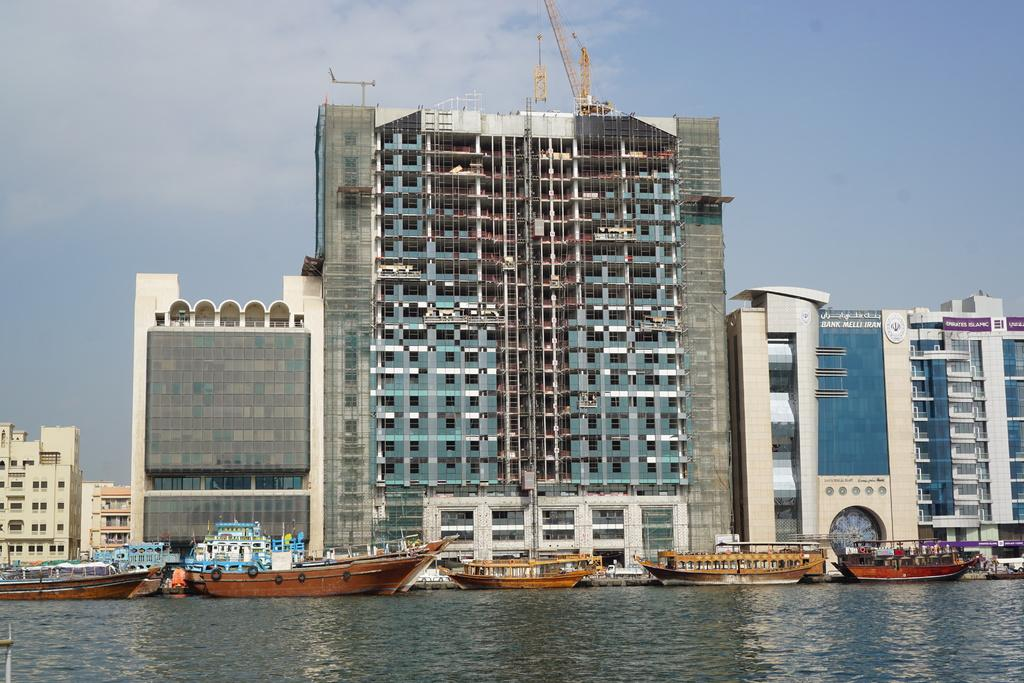What is floating on the water in the image? There are boats floating on the water in the image. What can be seen in the background of the image? There are buildings in the background of the image. What is visible in the sky in the image? There are clouds visible in the sky in the image. What type of bread can be seen floating on the water in the image? There is no bread present in the image; it features boats floating on the water. Can you see any twigs floating on the water in the image? There are no twigs visible in the image; only boats are present on the water. 